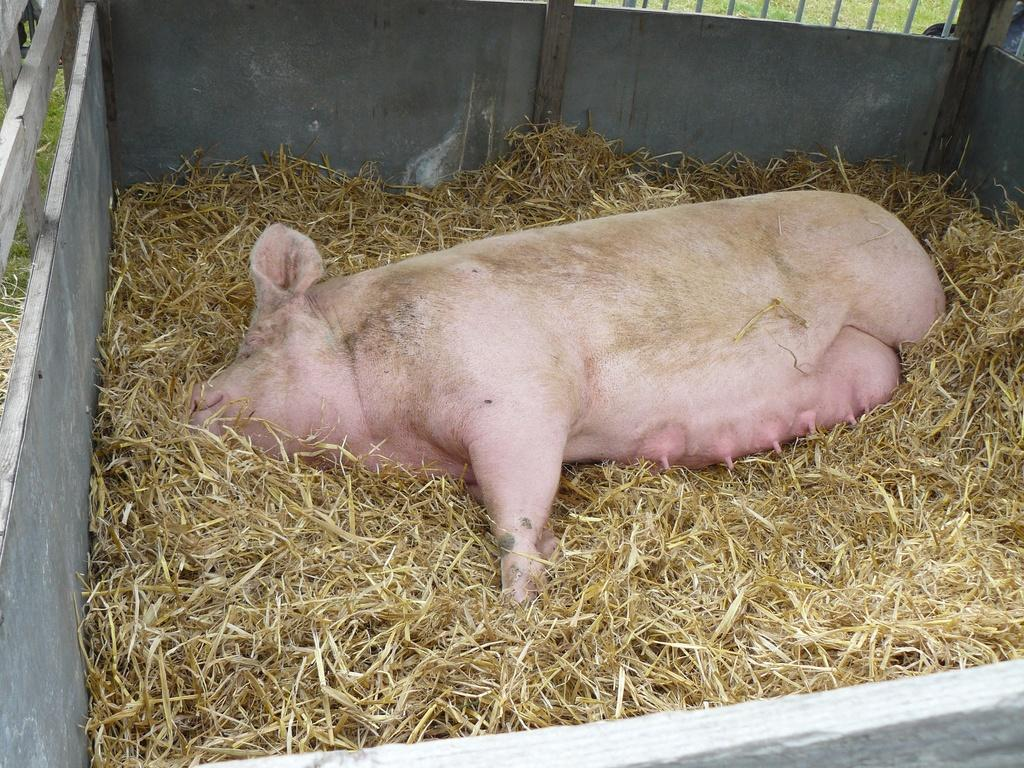What type of creature is present in the image? There is an animal in the image. Where is the animal located? The animal is in the grass. What type of pollution can be seen in the image? There is no pollution present in the image; it features an animal in the grass. Where is the nearest library to the location depicted in the image? The provided facts do not give any information about the location or the presence of a library, so it cannot be determined from the image. 